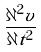Convert formula to latex. <formula><loc_0><loc_0><loc_500><loc_500>\frac { \partial ^ { 2 } v } { \partial t ^ { 2 } }</formula> 